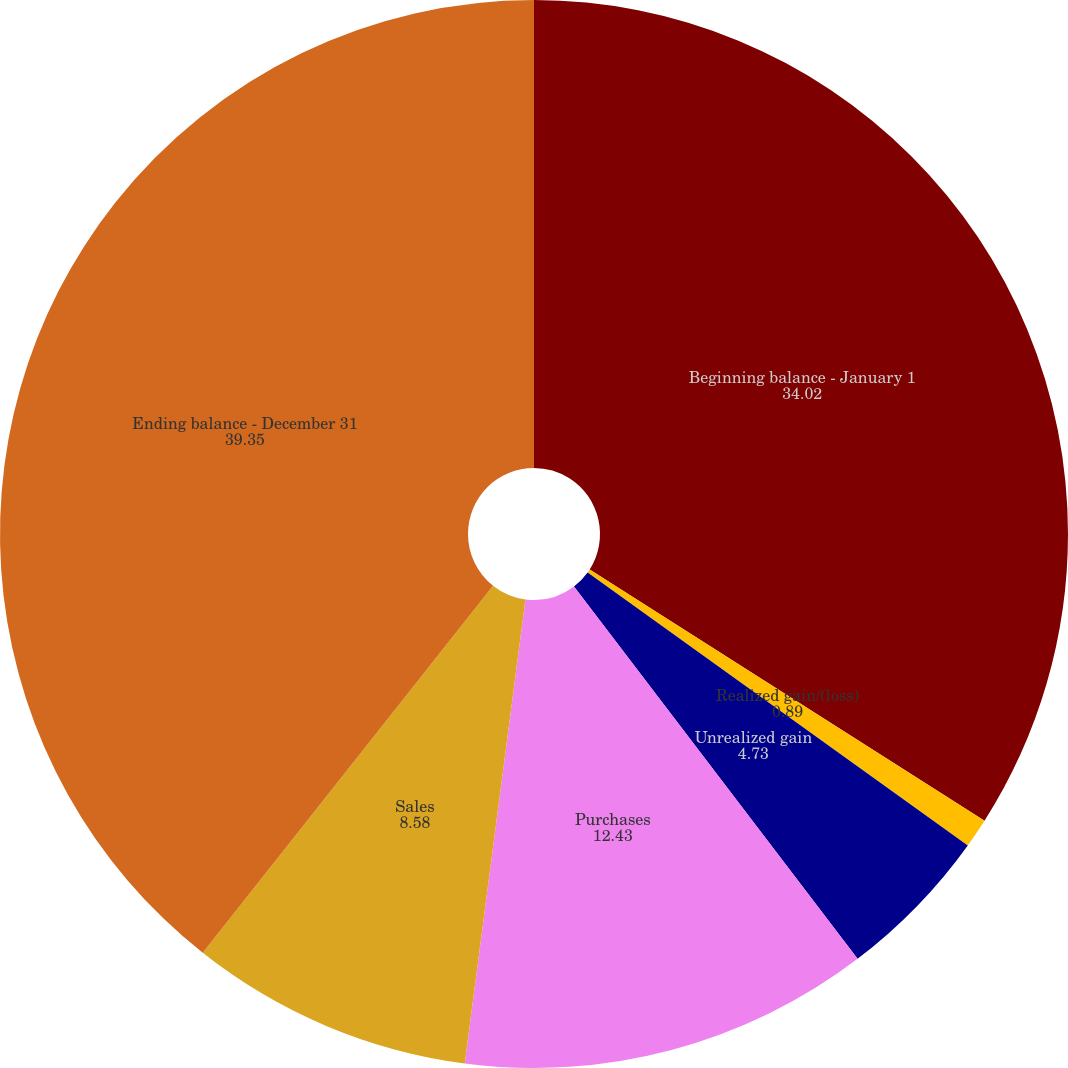<chart> <loc_0><loc_0><loc_500><loc_500><pie_chart><fcel>Beginning balance - January 1<fcel>Realized gain/(loss)<fcel>Unrealized gain<fcel>Purchases<fcel>Sales<fcel>Ending balance - December 31<nl><fcel>34.02%<fcel>0.89%<fcel>4.73%<fcel>12.43%<fcel>8.58%<fcel>39.35%<nl></chart> 